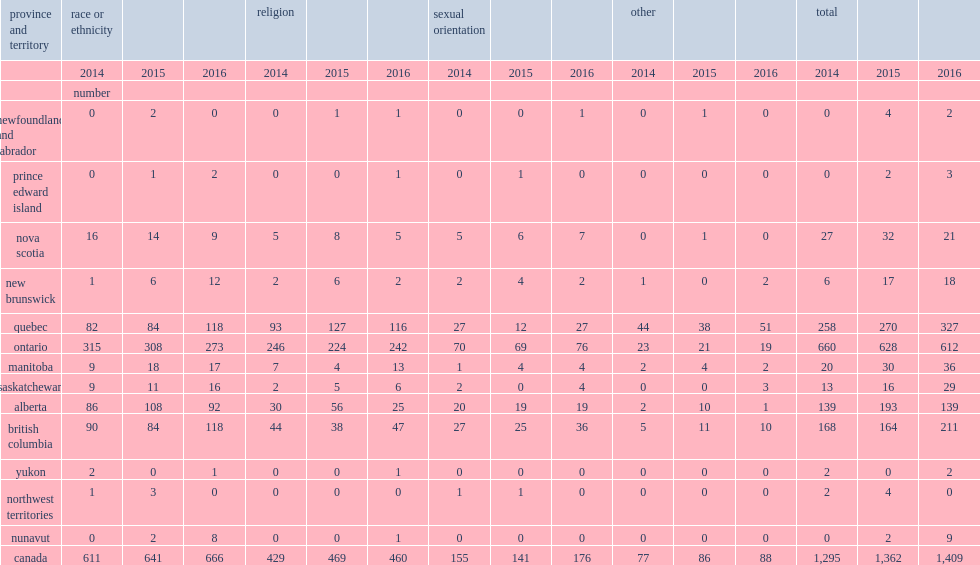Between 2015 and 2016, which province and territory reported the largest increase in the number of hate crimes? Quebec. 